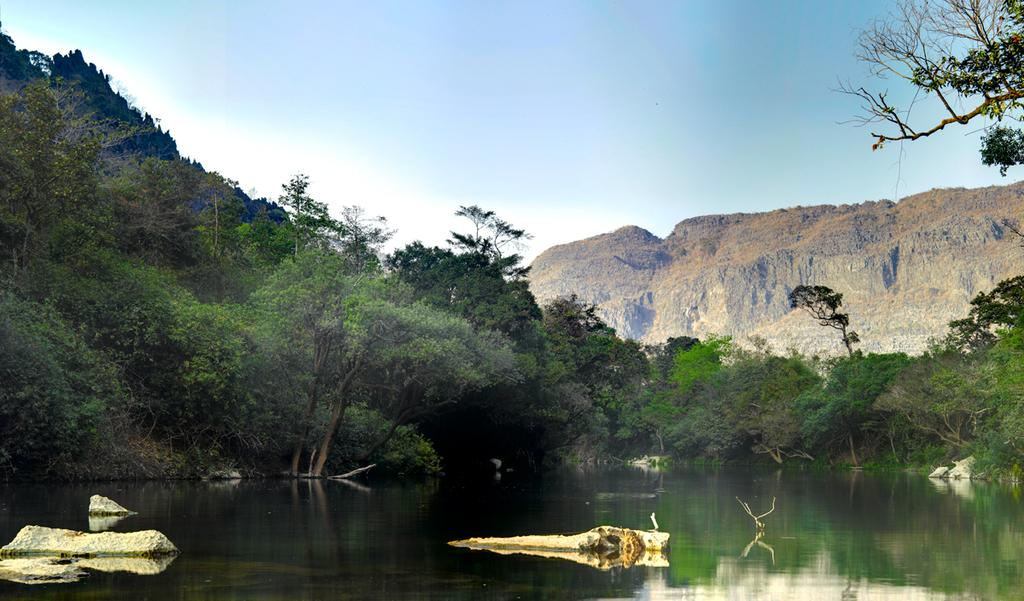What is one of the main elements in the picture? There is water in the picture. What type of natural environment can be seen in the picture? There are trees in the picture, which suggests a natural setting. What is visible in the background of the picture? The sky is visible in the picture. What is present in the water? There are objects in the water. What type of advertisement can be seen in the water? There is no advertisement present in the water or the image. How low is the fire in the picture? There is no fire present in the image. 